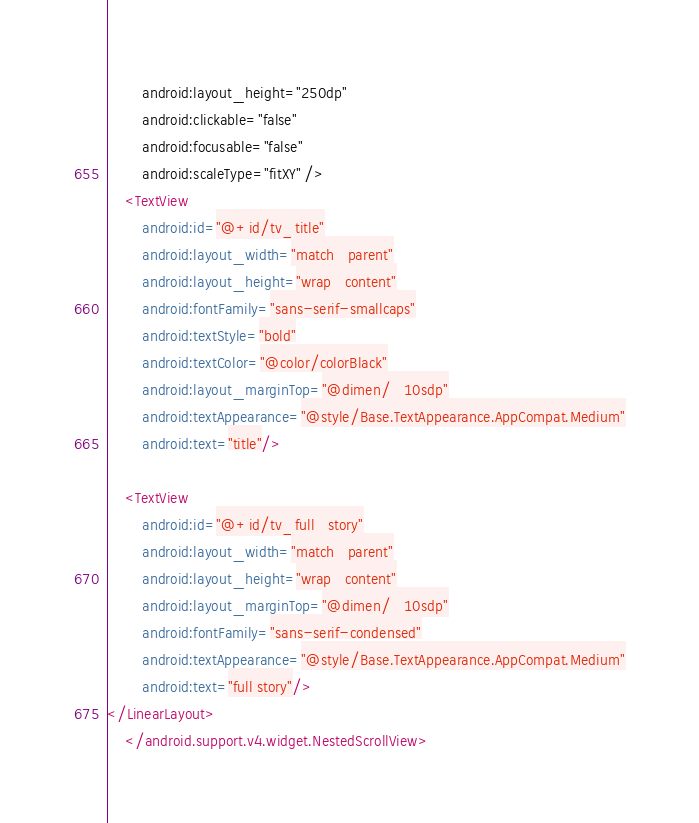Convert code to text. <code><loc_0><loc_0><loc_500><loc_500><_XML_>        android:layout_height="250dp"
        android:clickable="false"
        android:focusable="false"
        android:scaleType="fitXY" />
    <TextView
        android:id="@+id/tv_title"
        android:layout_width="match_parent"
        android:layout_height="wrap_content"
        android:fontFamily="sans-serif-smallcaps"
        android:textStyle="bold"
        android:textColor="@color/colorBlack"
        android:layout_marginTop="@dimen/_10sdp"
        android:textAppearance="@style/Base.TextAppearance.AppCompat.Medium"
        android:text="title"/>

    <TextView
        android:id="@+id/tv_full_story"
        android:layout_width="match_parent"
        android:layout_height="wrap_content"
        android:layout_marginTop="@dimen/_10sdp"
        android:fontFamily="sans-serif-condensed"
        android:textAppearance="@style/Base.TextAppearance.AppCompat.Medium"
        android:text="full story"/>
</LinearLayout>
    </android.support.v4.widget.NestedScrollView>
</code> 